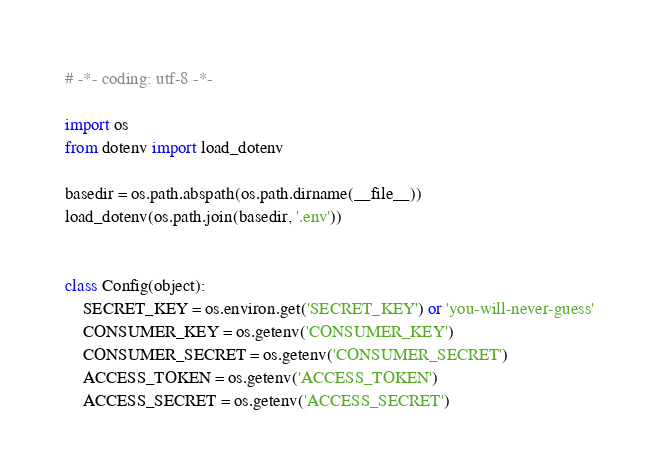Convert code to text. <code><loc_0><loc_0><loc_500><loc_500><_Python_># -*- coding: utf-8 -*-

import os
from dotenv import load_dotenv

basedir = os.path.abspath(os.path.dirname(__file__))
load_dotenv(os.path.join(basedir, '.env'))


class Config(object):
    SECRET_KEY = os.environ.get('SECRET_KEY') or 'you-will-never-guess'
    CONSUMER_KEY = os.getenv('CONSUMER_KEY')
    CONSUMER_SECRET = os.getenv('CONSUMER_SECRET')
    ACCESS_TOKEN = os.getenv('ACCESS_TOKEN')
    ACCESS_SECRET = os.getenv('ACCESS_SECRET')
</code> 